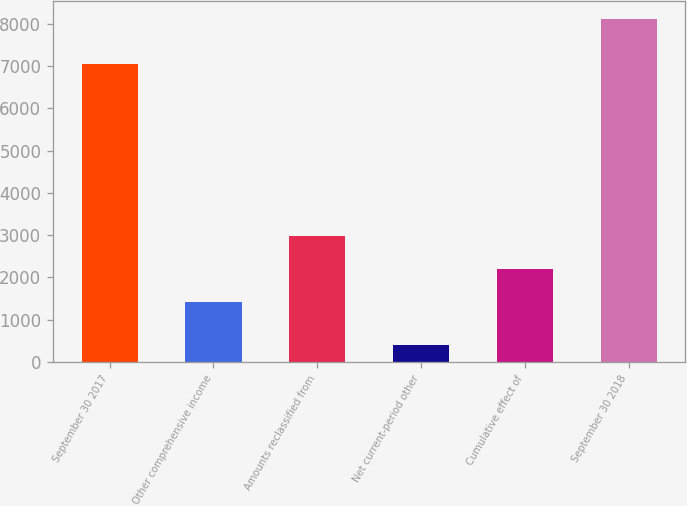Convert chart to OTSL. <chart><loc_0><loc_0><loc_500><loc_500><bar_chart><fcel>September 30 2017<fcel>Other comprehensive income<fcel>Amounts reclassified from<fcel>Net current-period other<fcel>Cumulative effect of<fcel>September 30 2018<nl><fcel>7048<fcel>1426<fcel>2971.8<fcel>395<fcel>2198.9<fcel>8124<nl></chart> 